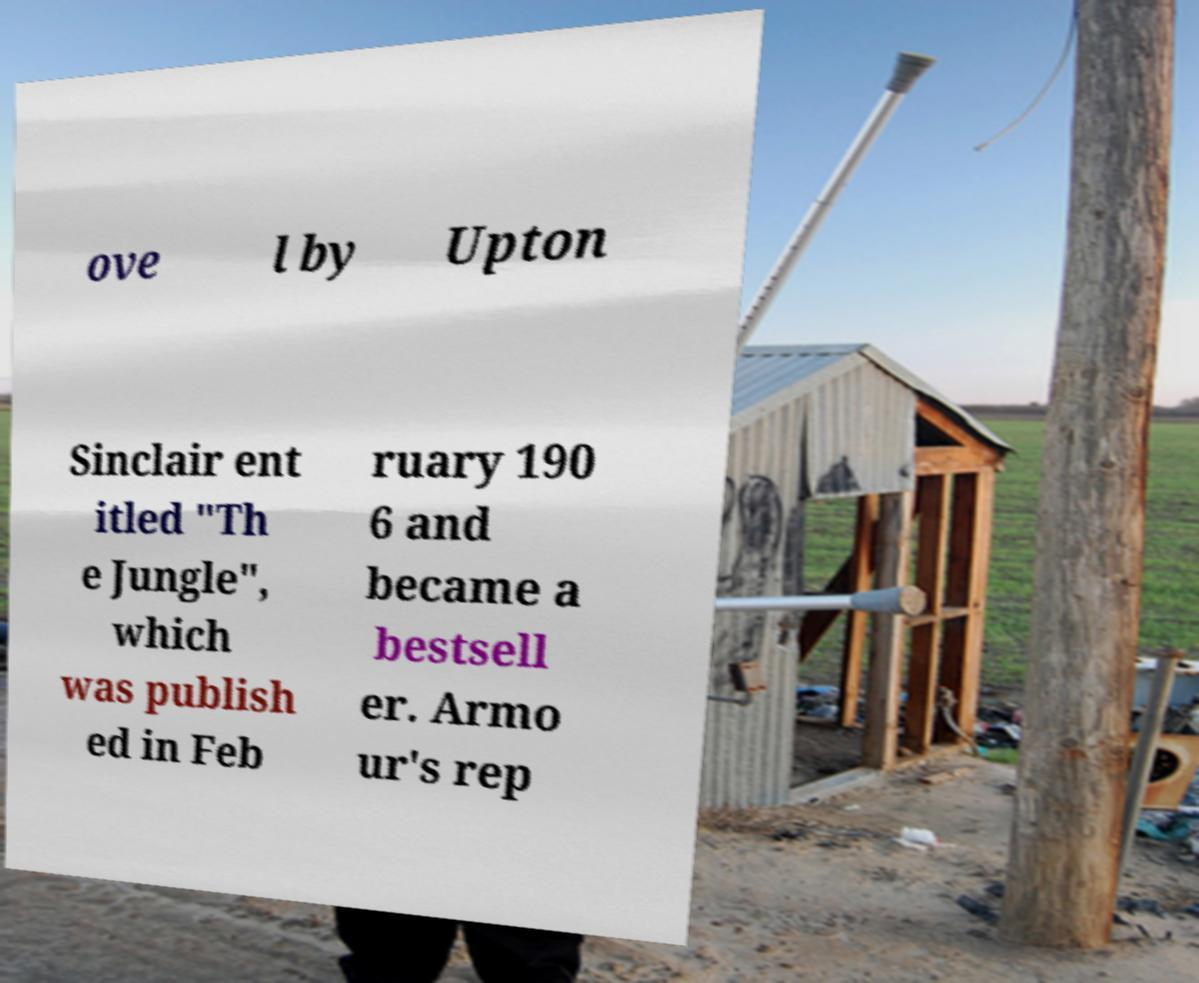Can you read and provide the text displayed in the image?This photo seems to have some interesting text. Can you extract and type it out for me? ove l by Upton Sinclair ent itled "Th e Jungle", which was publish ed in Feb ruary 190 6 and became a bestsell er. Armo ur's rep 